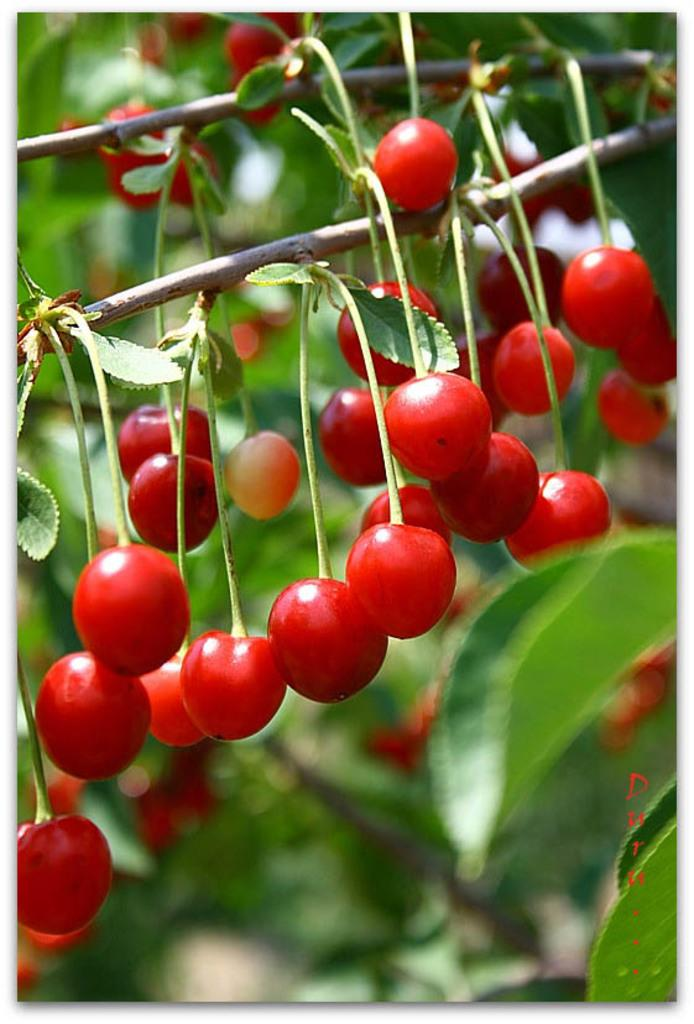What type of fruit is present in the image? There are cherries in the image. How are the cherries positioned in the image? The cherries are hanging from a plant in the image. What type of rain is falling on the cherries in the image? There is no rain present in the image; it only shows cherries hanging from a plant. 